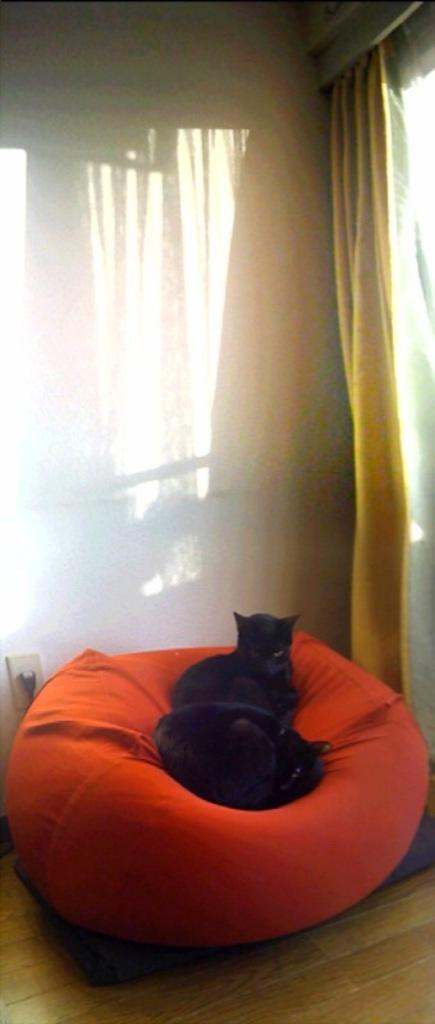How many cats are in the image? There are two cats in the image. What are the cats doing in the image? The cats are sitting on a bean bag. What can be seen in the background of the image? There is a wall in the background of the image. What type of window treatment is present in the image? There are curtains in the image. What type of shirt is the dog wearing in the image? There are no dogs present in the image, and therefore no dog wearing a shirt can be observed. 